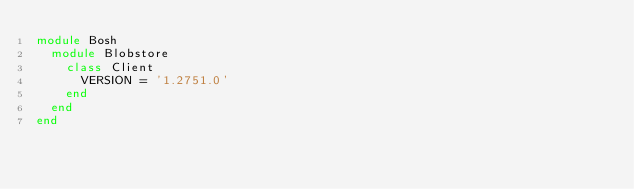<code> <loc_0><loc_0><loc_500><loc_500><_Ruby_>module Bosh
  module Blobstore
    class Client
      VERSION = '1.2751.0'
    end
  end
end
</code> 